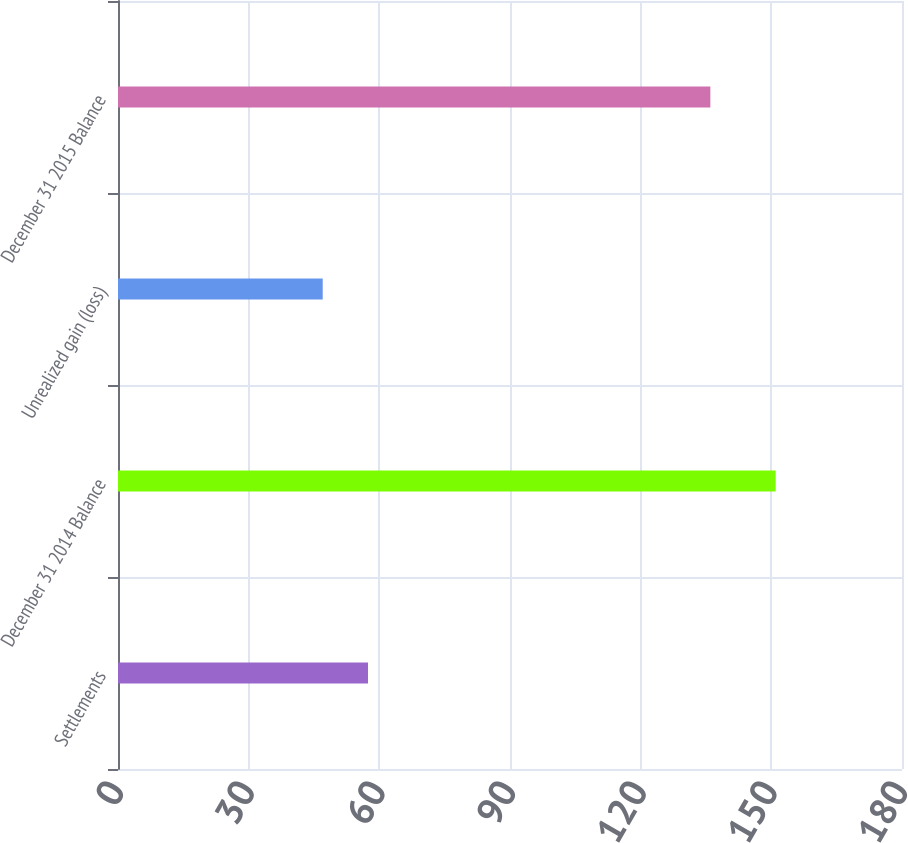<chart> <loc_0><loc_0><loc_500><loc_500><bar_chart><fcel>Settlements<fcel>December 31 2014 Balance<fcel>Unrealized gain (loss)<fcel>December 31 2015 Balance<nl><fcel>57.4<fcel>151<fcel>47<fcel>136<nl></chart> 